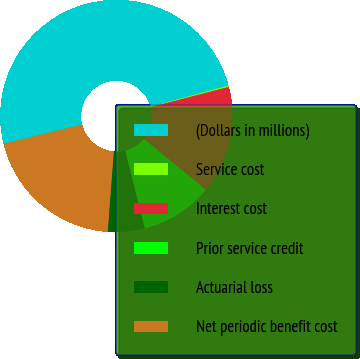Convert chart. <chart><loc_0><loc_0><loc_500><loc_500><pie_chart><fcel>(Dollars in millions)<fcel>Service cost<fcel>Interest cost<fcel>Prior service credit<fcel>Actuarial loss<fcel>Net periodic benefit cost<nl><fcel>49.6%<fcel>0.2%<fcel>15.02%<fcel>10.08%<fcel>5.14%<fcel>19.96%<nl></chart> 